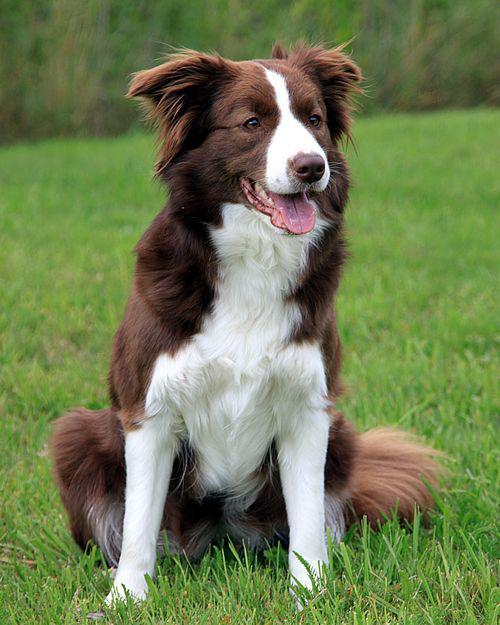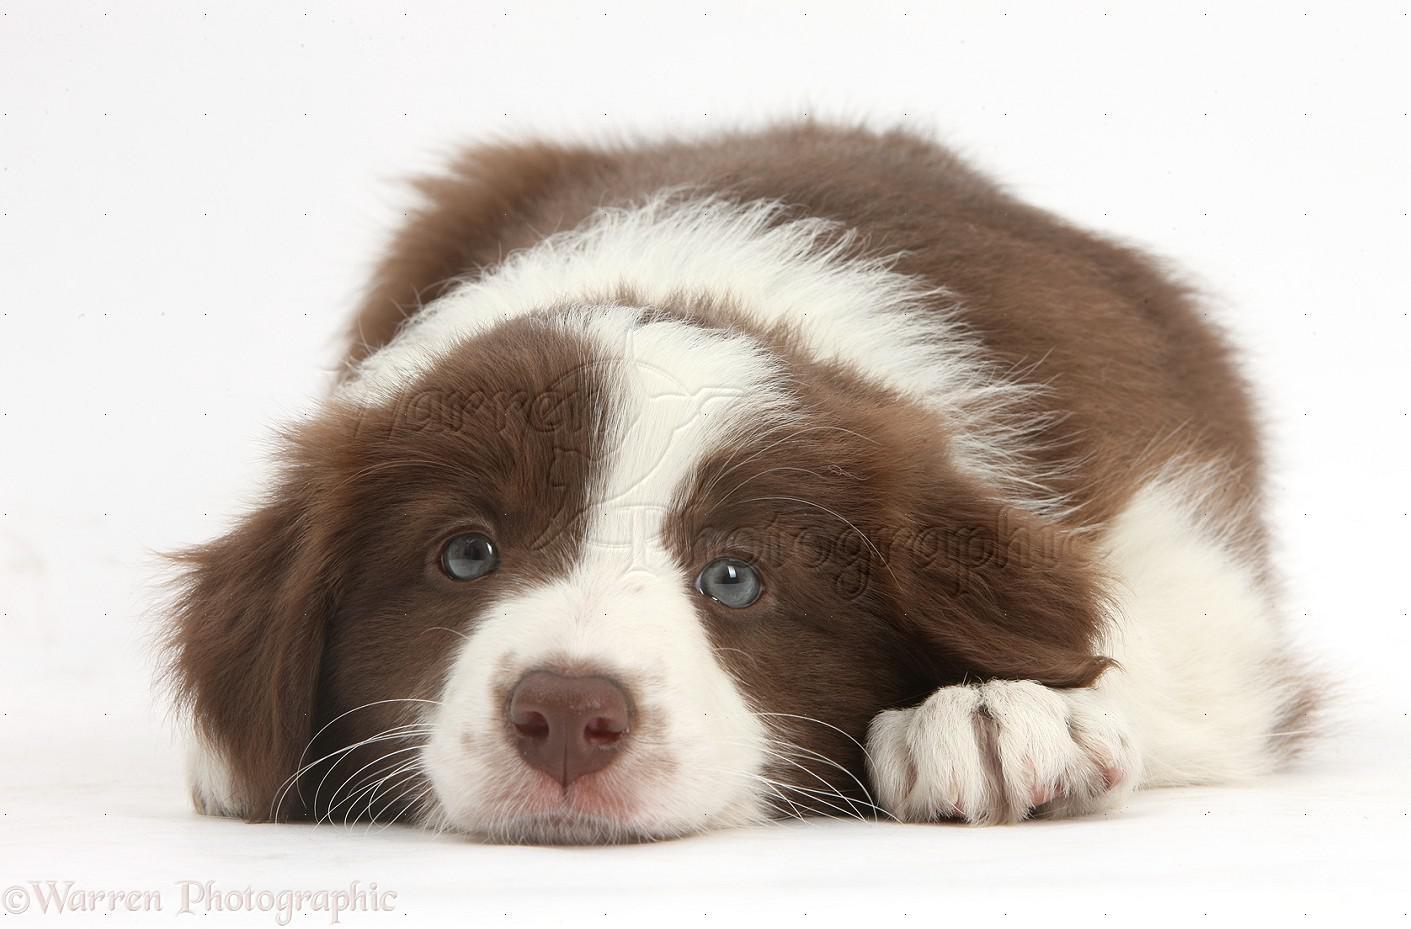The first image is the image on the left, the second image is the image on the right. Evaluate the accuracy of this statement regarding the images: "One brown and white dog has its mouth open with tongue showing and one does not, but both have wide white bands of color between their eyes.". Is it true? Answer yes or no. Yes. The first image is the image on the left, the second image is the image on the right. Given the left and right images, does the statement "The combined images include two brown-and-white dogs reclining with front paws extended forward." hold true? Answer yes or no. No. 